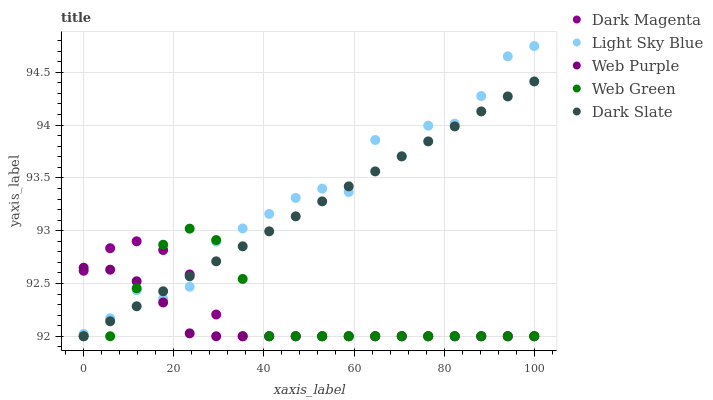Does Web Purple have the minimum area under the curve?
Answer yes or no. Yes. Does Light Sky Blue have the maximum area under the curve?
Answer yes or no. Yes. Does Light Sky Blue have the minimum area under the curve?
Answer yes or no. No. Does Web Purple have the maximum area under the curve?
Answer yes or no. No. Is Dark Slate the smoothest?
Answer yes or no. Yes. Is Light Sky Blue the roughest?
Answer yes or no. Yes. Is Web Purple the smoothest?
Answer yes or no. No. Is Web Purple the roughest?
Answer yes or no. No. Does Dark Slate have the lowest value?
Answer yes or no. Yes. Does Light Sky Blue have the lowest value?
Answer yes or no. No. Does Light Sky Blue have the highest value?
Answer yes or no. Yes. Does Web Purple have the highest value?
Answer yes or no. No. Does Web Green intersect Web Purple?
Answer yes or no. Yes. Is Web Green less than Web Purple?
Answer yes or no. No. Is Web Green greater than Web Purple?
Answer yes or no. No. 